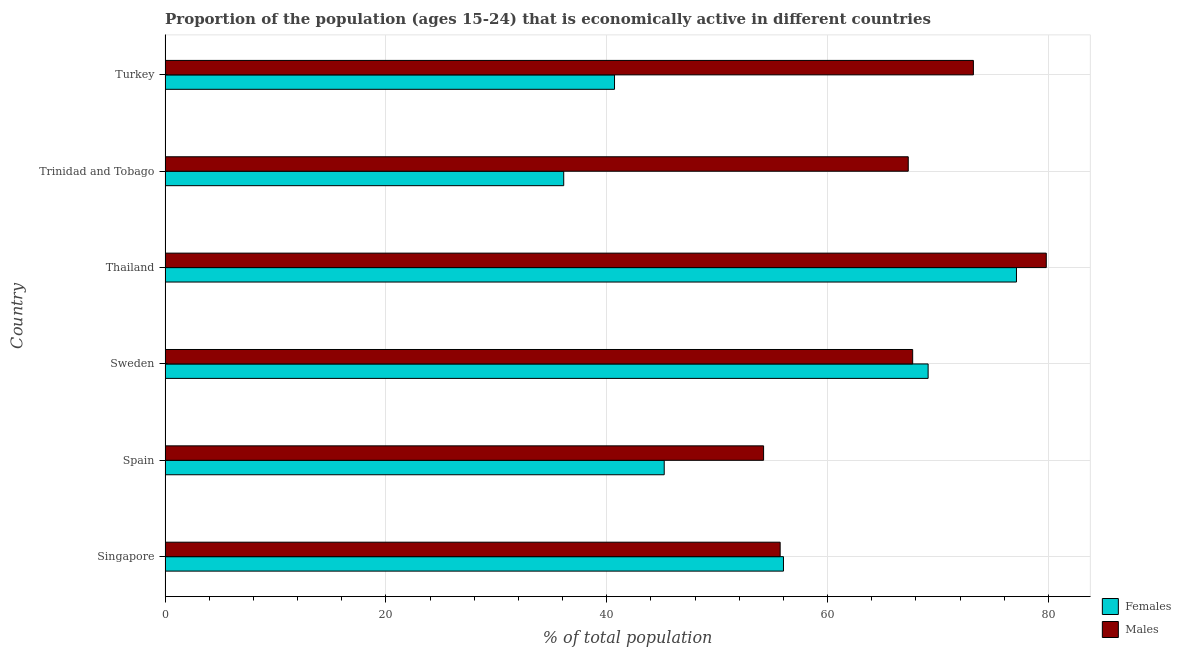How many groups of bars are there?
Your answer should be very brief. 6. Are the number of bars per tick equal to the number of legend labels?
Offer a terse response. Yes. What is the label of the 4th group of bars from the top?
Offer a very short reply. Sweden. What is the percentage of economically active female population in Trinidad and Tobago?
Provide a succinct answer. 36.1. Across all countries, what is the maximum percentage of economically active female population?
Your answer should be very brief. 77.1. Across all countries, what is the minimum percentage of economically active female population?
Make the answer very short. 36.1. In which country was the percentage of economically active male population maximum?
Your answer should be compact. Thailand. What is the total percentage of economically active female population in the graph?
Give a very brief answer. 324.2. What is the difference between the percentage of economically active female population in Spain and that in Thailand?
Make the answer very short. -31.9. What is the difference between the percentage of economically active female population in Sweden and the percentage of economically active male population in Singapore?
Ensure brevity in your answer.  13.4. What is the average percentage of economically active male population per country?
Provide a short and direct response. 66.32. What is the difference between the percentage of economically active male population and percentage of economically active female population in Sweden?
Your answer should be compact. -1.4. In how many countries, is the percentage of economically active male population greater than 4 %?
Offer a terse response. 6. What is the ratio of the percentage of economically active female population in Thailand to that in Trinidad and Tobago?
Your answer should be compact. 2.14. Is the percentage of economically active female population in Singapore less than that in Thailand?
Offer a very short reply. Yes. In how many countries, is the percentage of economically active male population greater than the average percentage of economically active male population taken over all countries?
Your answer should be very brief. 4. What does the 1st bar from the top in Thailand represents?
Provide a short and direct response. Males. What does the 2nd bar from the bottom in Turkey represents?
Give a very brief answer. Males. Are all the bars in the graph horizontal?
Your answer should be very brief. Yes. Does the graph contain any zero values?
Your answer should be very brief. No. Does the graph contain grids?
Provide a short and direct response. Yes. Where does the legend appear in the graph?
Give a very brief answer. Bottom right. How many legend labels are there?
Provide a succinct answer. 2. How are the legend labels stacked?
Offer a terse response. Vertical. What is the title of the graph?
Make the answer very short. Proportion of the population (ages 15-24) that is economically active in different countries. Does "Female entrants" appear as one of the legend labels in the graph?
Provide a succinct answer. No. What is the label or title of the X-axis?
Ensure brevity in your answer.  % of total population. What is the label or title of the Y-axis?
Give a very brief answer. Country. What is the % of total population in Males in Singapore?
Offer a very short reply. 55.7. What is the % of total population of Females in Spain?
Your response must be concise. 45.2. What is the % of total population in Males in Spain?
Your answer should be compact. 54.2. What is the % of total population of Females in Sweden?
Make the answer very short. 69.1. What is the % of total population of Males in Sweden?
Your answer should be compact. 67.7. What is the % of total population in Females in Thailand?
Your response must be concise. 77.1. What is the % of total population of Males in Thailand?
Make the answer very short. 79.8. What is the % of total population in Females in Trinidad and Tobago?
Provide a short and direct response. 36.1. What is the % of total population of Males in Trinidad and Tobago?
Provide a succinct answer. 67.3. What is the % of total population in Females in Turkey?
Your answer should be compact. 40.7. What is the % of total population in Males in Turkey?
Provide a short and direct response. 73.2. Across all countries, what is the maximum % of total population in Females?
Provide a short and direct response. 77.1. Across all countries, what is the maximum % of total population of Males?
Give a very brief answer. 79.8. Across all countries, what is the minimum % of total population in Females?
Your answer should be compact. 36.1. Across all countries, what is the minimum % of total population of Males?
Your answer should be very brief. 54.2. What is the total % of total population of Females in the graph?
Your answer should be compact. 324.2. What is the total % of total population in Males in the graph?
Keep it short and to the point. 397.9. What is the difference between the % of total population in Females in Singapore and that in Spain?
Your response must be concise. 10.8. What is the difference between the % of total population in Males in Singapore and that in Spain?
Provide a short and direct response. 1.5. What is the difference between the % of total population of Females in Singapore and that in Thailand?
Provide a short and direct response. -21.1. What is the difference between the % of total population of Males in Singapore and that in Thailand?
Offer a very short reply. -24.1. What is the difference between the % of total population in Females in Singapore and that in Trinidad and Tobago?
Your answer should be very brief. 19.9. What is the difference between the % of total population in Males in Singapore and that in Trinidad and Tobago?
Provide a succinct answer. -11.6. What is the difference between the % of total population in Males in Singapore and that in Turkey?
Offer a terse response. -17.5. What is the difference between the % of total population in Females in Spain and that in Sweden?
Offer a terse response. -23.9. What is the difference between the % of total population of Males in Spain and that in Sweden?
Your answer should be compact. -13.5. What is the difference between the % of total population in Females in Spain and that in Thailand?
Your answer should be compact. -31.9. What is the difference between the % of total population of Males in Spain and that in Thailand?
Offer a very short reply. -25.6. What is the difference between the % of total population in Females in Spain and that in Trinidad and Tobago?
Ensure brevity in your answer.  9.1. What is the difference between the % of total population in Males in Spain and that in Trinidad and Tobago?
Provide a succinct answer. -13.1. What is the difference between the % of total population of Males in Spain and that in Turkey?
Keep it short and to the point. -19. What is the difference between the % of total population in Females in Sweden and that in Thailand?
Offer a very short reply. -8. What is the difference between the % of total population of Males in Sweden and that in Trinidad and Tobago?
Ensure brevity in your answer.  0.4. What is the difference between the % of total population of Females in Sweden and that in Turkey?
Your response must be concise. 28.4. What is the difference between the % of total population in Females in Thailand and that in Trinidad and Tobago?
Give a very brief answer. 41. What is the difference between the % of total population in Males in Thailand and that in Trinidad and Tobago?
Keep it short and to the point. 12.5. What is the difference between the % of total population of Females in Thailand and that in Turkey?
Your answer should be very brief. 36.4. What is the difference between the % of total population of Females in Trinidad and Tobago and that in Turkey?
Offer a terse response. -4.6. What is the difference between the % of total population in Females in Singapore and the % of total population in Males in Thailand?
Your response must be concise. -23.8. What is the difference between the % of total population of Females in Singapore and the % of total population of Males in Turkey?
Your answer should be compact. -17.2. What is the difference between the % of total population of Females in Spain and the % of total population of Males in Sweden?
Offer a very short reply. -22.5. What is the difference between the % of total population of Females in Spain and the % of total population of Males in Thailand?
Your answer should be compact. -34.6. What is the difference between the % of total population of Females in Spain and the % of total population of Males in Trinidad and Tobago?
Offer a terse response. -22.1. What is the difference between the % of total population in Females in Spain and the % of total population in Males in Turkey?
Keep it short and to the point. -28. What is the difference between the % of total population in Females in Trinidad and Tobago and the % of total population in Males in Turkey?
Your answer should be very brief. -37.1. What is the average % of total population in Females per country?
Provide a short and direct response. 54.03. What is the average % of total population in Males per country?
Your answer should be very brief. 66.32. What is the difference between the % of total population in Females and % of total population in Males in Singapore?
Your response must be concise. 0.3. What is the difference between the % of total population of Females and % of total population of Males in Sweden?
Your response must be concise. 1.4. What is the difference between the % of total population of Females and % of total population of Males in Thailand?
Provide a succinct answer. -2.7. What is the difference between the % of total population of Females and % of total population of Males in Trinidad and Tobago?
Offer a very short reply. -31.2. What is the difference between the % of total population in Females and % of total population in Males in Turkey?
Give a very brief answer. -32.5. What is the ratio of the % of total population in Females in Singapore to that in Spain?
Your answer should be very brief. 1.24. What is the ratio of the % of total population in Males in Singapore to that in Spain?
Your answer should be compact. 1.03. What is the ratio of the % of total population in Females in Singapore to that in Sweden?
Your answer should be very brief. 0.81. What is the ratio of the % of total population of Males in Singapore to that in Sweden?
Make the answer very short. 0.82. What is the ratio of the % of total population of Females in Singapore to that in Thailand?
Make the answer very short. 0.73. What is the ratio of the % of total population of Males in Singapore to that in Thailand?
Keep it short and to the point. 0.7. What is the ratio of the % of total population in Females in Singapore to that in Trinidad and Tobago?
Provide a short and direct response. 1.55. What is the ratio of the % of total population in Males in Singapore to that in Trinidad and Tobago?
Your answer should be very brief. 0.83. What is the ratio of the % of total population in Females in Singapore to that in Turkey?
Your answer should be compact. 1.38. What is the ratio of the % of total population in Males in Singapore to that in Turkey?
Keep it short and to the point. 0.76. What is the ratio of the % of total population of Females in Spain to that in Sweden?
Make the answer very short. 0.65. What is the ratio of the % of total population in Males in Spain to that in Sweden?
Offer a very short reply. 0.8. What is the ratio of the % of total population of Females in Spain to that in Thailand?
Your response must be concise. 0.59. What is the ratio of the % of total population of Males in Spain to that in Thailand?
Give a very brief answer. 0.68. What is the ratio of the % of total population in Females in Spain to that in Trinidad and Tobago?
Offer a terse response. 1.25. What is the ratio of the % of total population of Males in Spain to that in Trinidad and Tobago?
Give a very brief answer. 0.81. What is the ratio of the % of total population in Females in Spain to that in Turkey?
Provide a succinct answer. 1.11. What is the ratio of the % of total population of Males in Spain to that in Turkey?
Ensure brevity in your answer.  0.74. What is the ratio of the % of total population of Females in Sweden to that in Thailand?
Your response must be concise. 0.9. What is the ratio of the % of total population in Males in Sweden to that in Thailand?
Make the answer very short. 0.85. What is the ratio of the % of total population of Females in Sweden to that in Trinidad and Tobago?
Provide a short and direct response. 1.91. What is the ratio of the % of total population in Males in Sweden to that in Trinidad and Tobago?
Provide a short and direct response. 1.01. What is the ratio of the % of total population of Females in Sweden to that in Turkey?
Keep it short and to the point. 1.7. What is the ratio of the % of total population in Males in Sweden to that in Turkey?
Provide a succinct answer. 0.92. What is the ratio of the % of total population in Females in Thailand to that in Trinidad and Tobago?
Give a very brief answer. 2.14. What is the ratio of the % of total population of Males in Thailand to that in Trinidad and Tobago?
Provide a succinct answer. 1.19. What is the ratio of the % of total population in Females in Thailand to that in Turkey?
Your response must be concise. 1.89. What is the ratio of the % of total population in Males in Thailand to that in Turkey?
Make the answer very short. 1.09. What is the ratio of the % of total population in Females in Trinidad and Tobago to that in Turkey?
Offer a very short reply. 0.89. What is the ratio of the % of total population in Males in Trinidad and Tobago to that in Turkey?
Your answer should be very brief. 0.92. What is the difference between the highest and the lowest % of total population in Males?
Offer a terse response. 25.6. 